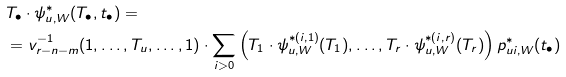<formula> <loc_0><loc_0><loc_500><loc_500>& T _ { \bullet } \cdot \psi _ { u , W } ^ { \ast } ( T _ { \bullet } , t _ { \bullet } ) = \\ & = v _ { r - n - m } ^ { - 1 } ( 1 , \dots , T _ { u } , \dots , 1 ) \cdot \sum _ { i > 0 } \left ( T _ { 1 } \cdot \psi _ { u , W } ^ { \ast ( i , 1 ) } ( T _ { 1 } ) , \dots , T _ { r } \cdot \psi _ { u , W } ^ { \ast ( i , r ) } ( T _ { r } ) \right ) p _ { u i , W } ^ { \ast } ( t _ { \bullet } )</formula> 